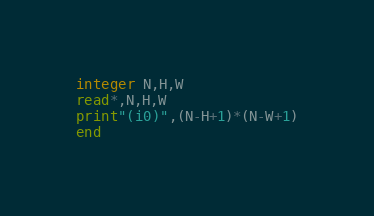<code> <loc_0><loc_0><loc_500><loc_500><_FORTRAN_>integer N,H,W
read*,N,H,W
print"(i0)",(N-H+1)*(N-W+1)
end</code> 